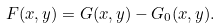Convert formula to latex. <formula><loc_0><loc_0><loc_500><loc_500>F ( x , y ) = G ( x , y ) - G _ { 0 } ( x , y ) .</formula> 